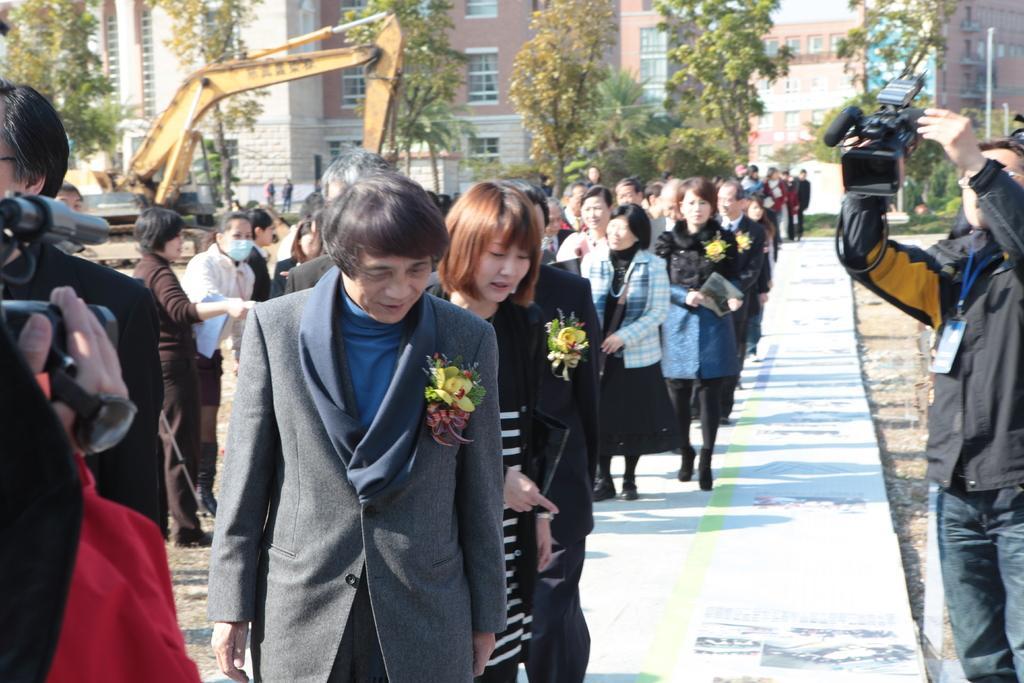Could you give a brief overview of what you see in this image? In this image I can see few people are walking and wearing different dress. One person is holding camera. Back I can see a crane,buildings,windows and trees. 